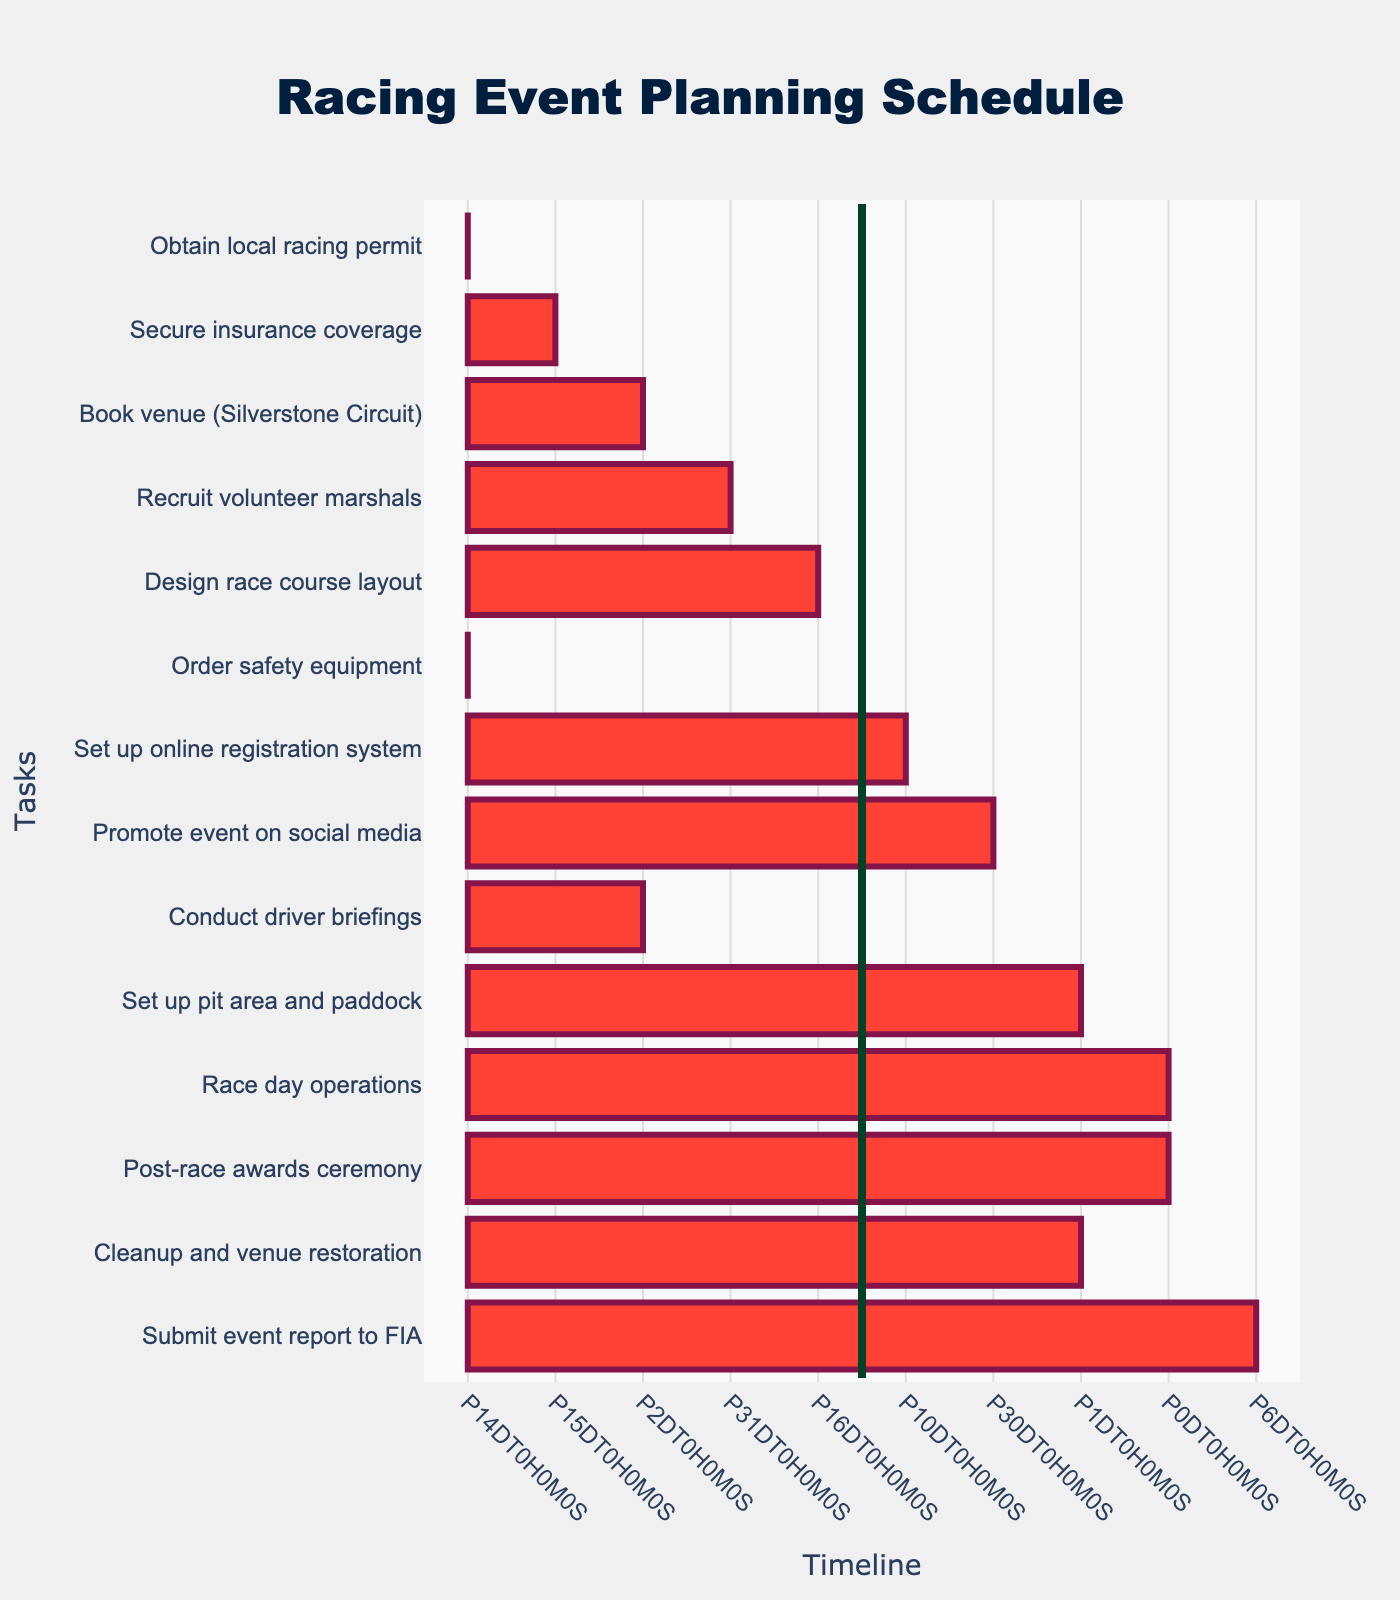What is the title of the Gantt chart? The title of the Gantt chart can be found at the top center of the chart.
Answer: Racing Event Planning Schedule How long does it take to obtain the local racing permit? Locate "Obtain local racing permit" task and look at the duration indicated in the hover text.
Answer: 14 days Which task takes the longest duration to complete? Compare the duration of all tasks listed in the chart's hover text and identify the one with the highest value.
Answer: Recruit volunteer marshals What is the end date for setting up the online registration system? Hover over the "Set up online registration system" task and check the end date displayed.
Answer: 2023-06-20 Calculate the total number of days from the start date of obtaining the local racing permit to the end date of submitting the event report to FIA. Identify the start date of "Obtain local racing permit" and end date of "Submit event report to FIA," then calculate the difference between these dates. The start date is 2023-05-01 and the end date is 2023-08-05, totaling 96 days.
Answer: 96 days What tasks are scheduled to start after 2023-07-20? Check the start dates of all tasks and identify those starting after 2023-07-20.
Answer: Set up pit area and paddock, Race day operations, Post-race awards ceremony, Cleanup and venue restoration, Submit event report to FIA Which tasks overlap in the month of June? Look at the Gantt chart and identify tasks that have durations overlapping in June.
Answer: Recruit volunteer marshals, Design race course layout, Order safety equipment, Set up online registration system Compare the duration between ordering safety equipment and submitting the event report to FIA. Which one takes longer? Find the duration of both tasks in the hover text and compare them. Ordering safety equipment takes 14 days and submitting the event report to FIA takes 6 days.
Answer: Ordering safety equipment How many tasks are scheduled to start in May? Count all the tasks that have start dates in May.
Answer: 5 tasks 